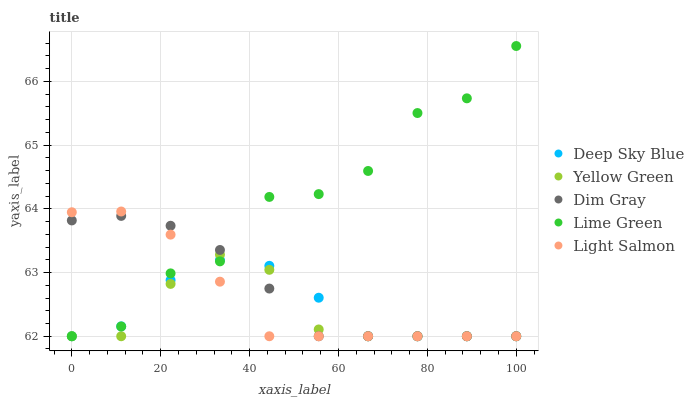Does Yellow Green have the minimum area under the curve?
Answer yes or no. Yes. Does Lime Green have the maximum area under the curve?
Answer yes or no. Yes. Does Dim Gray have the minimum area under the curve?
Answer yes or no. No. Does Dim Gray have the maximum area under the curve?
Answer yes or no. No. Is Dim Gray the smoothest?
Answer yes or no. Yes. Is Lime Green the roughest?
Answer yes or no. Yes. Is Lime Green the smoothest?
Answer yes or no. No. Is Dim Gray the roughest?
Answer yes or no. No. Does Light Salmon have the lowest value?
Answer yes or no. Yes. Does Lime Green have the highest value?
Answer yes or no. Yes. Does Dim Gray have the highest value?
Answer yes or no. No. Does Deep Sky Blue intersect Yellow Green?
Answer yes or no. Yes. Is Deep Sky Blue less than Yellow Green?
Answer yes or no. No. Is Deep Sky Blue greater than Yellow Green?
Answer yes or no. No. 